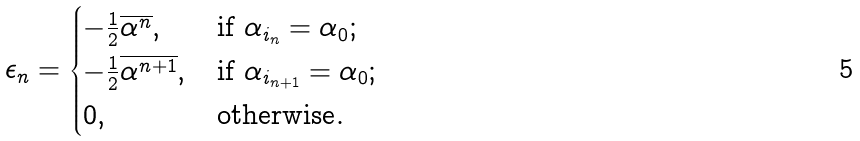Convert formula to latex. <formula><loc_0><loc_0><loc_500><loc_500>\epsilon _ { n } = \begin{cases} - \frac { 1 } { 2 } \overline { \alpha ^ { n } } , \quad & \text {if } \alpha _ { i _ { n } } = \alpha _ { 0 } ; \\ - \frac { 1 } { 2 } \overline { \alpha ^ { n + 1 } } , & \text {if } \alpha _ { i _ { n + 1 } } = \alpha _ { 0 } ; \\ 0 , & \text {otherwise} . \\ \end{cases}</formula> 